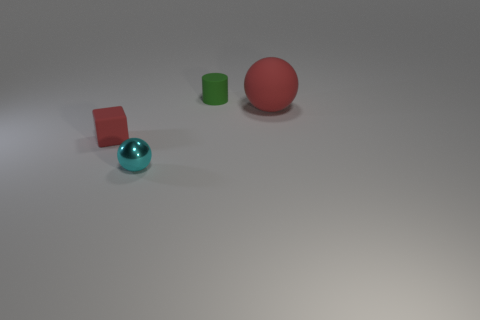Add 3 small green metallic balls. How many objects exist? 7 Subtract all cubes. How many objects are left? 3 Subtract all small blue cylinders. Subtract all big rubber things. How many objects are left? 3 Add 2 cyan spheres. How many cyan spheres are left? 3 Add 1 green cylinders. How many green cylinders exist? 2 Subtract 0 red cylinders. How many objects are left? 4 